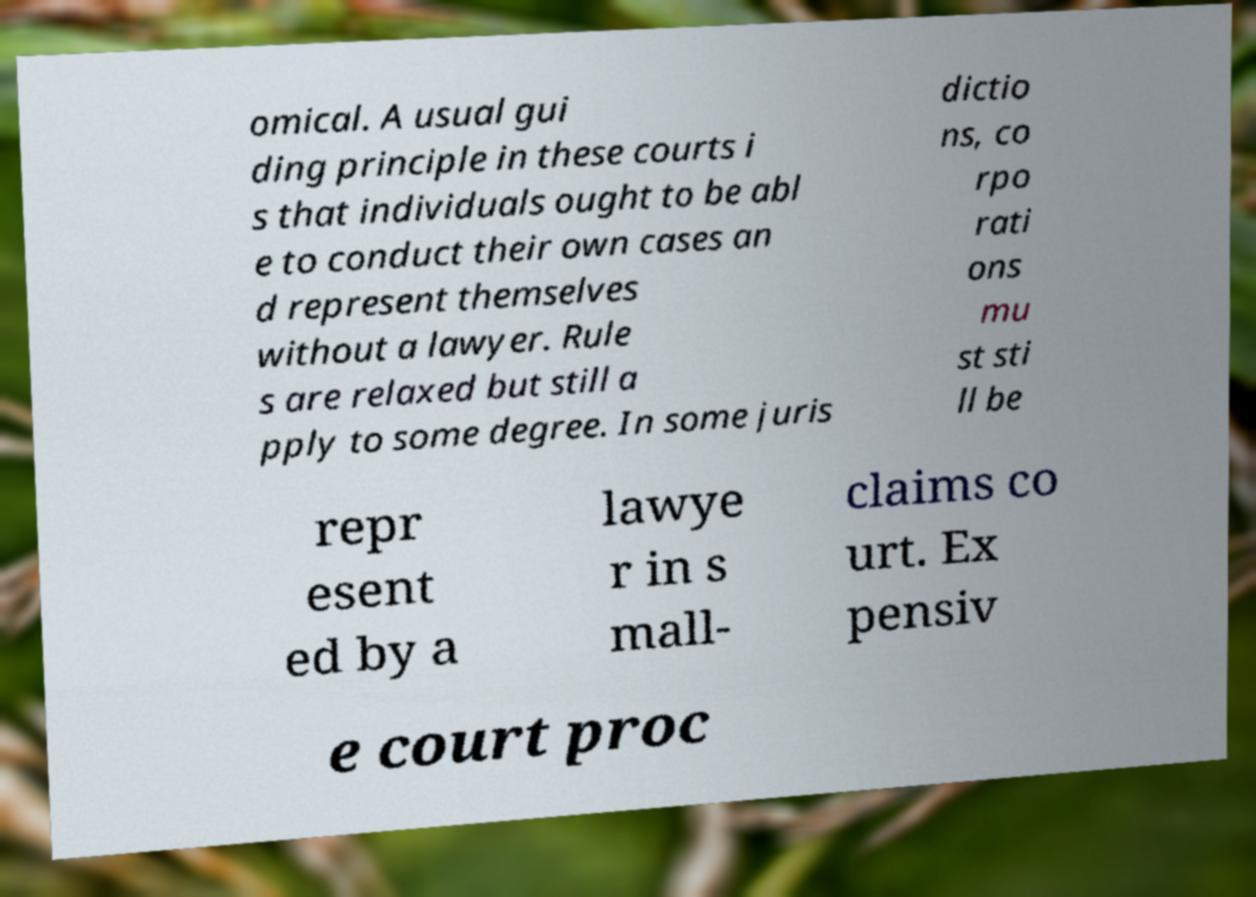Please read and relay the text visible in this image. What does it say? omical. A usual gui ding principle in these courts i s that individuals ought to be abl e to conduct their own cases an d represent themselves without a lawyer. Rule s are relaxed but still a pply to some degree. In some juris dictio ns, co rpo rati ons mu st sti ll be repr esent ed by a lawye r in s mall- claims co urt. Ex pensiv e court proc 